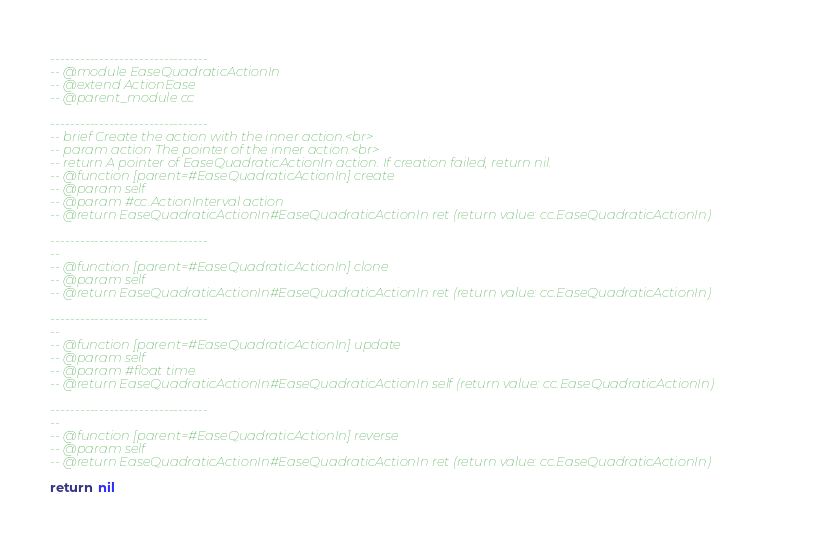Convert code to text. <code><loc_0><loc_0><loc_500><loc_500><_Lua_>--------------------------------
-- @module EaseQuadraticActionIn
-- @extend ActionEase
-- @parent_module cc

--------------------------------
-- brief Create the action with the inner action.<br>
-- param action The pointer of the inner action.<br>
-- return A pointer of EaseQuadraticActionIn action. If creation failed, return nil.
-- @function [parent=#EaseQuadraticActionIn] create 
-- @param self
-- @param #cc.ActionInterval action
-- @return EaseQuadraticActionIn#EaseQuadraticActionIn ret (return value: cc.EaseQuadraticActionIn)
        
--------------------------------
-- 
-- @function [parent=#EaseQuadraticActionIn] clone 
-- @param self
-- @return EaseQuadraticActionIn#EaseQuadraticActionIn ret (return value: cc.EaseQuadraticActionIn)
        
--------------------------------
-- 
-- @function [parent=#EaseQuadraticActionIn] update 
-- @param self
-- @param #float time
-- @return EaseQuadraticActionIn#EaseQuadraticActionIn self (return value: cc.EaseQuadraticActionIn)
        
--------------------------------
-- 
-- @function [parent=#EaseQuadraticActionIn] reverse 
-- @param self
-- @return EaseQuadraticActionIn#EaseQuadraticActionIn ret (return value: cc.EaseQuadraticActionIn)
        
return nil
</code> 